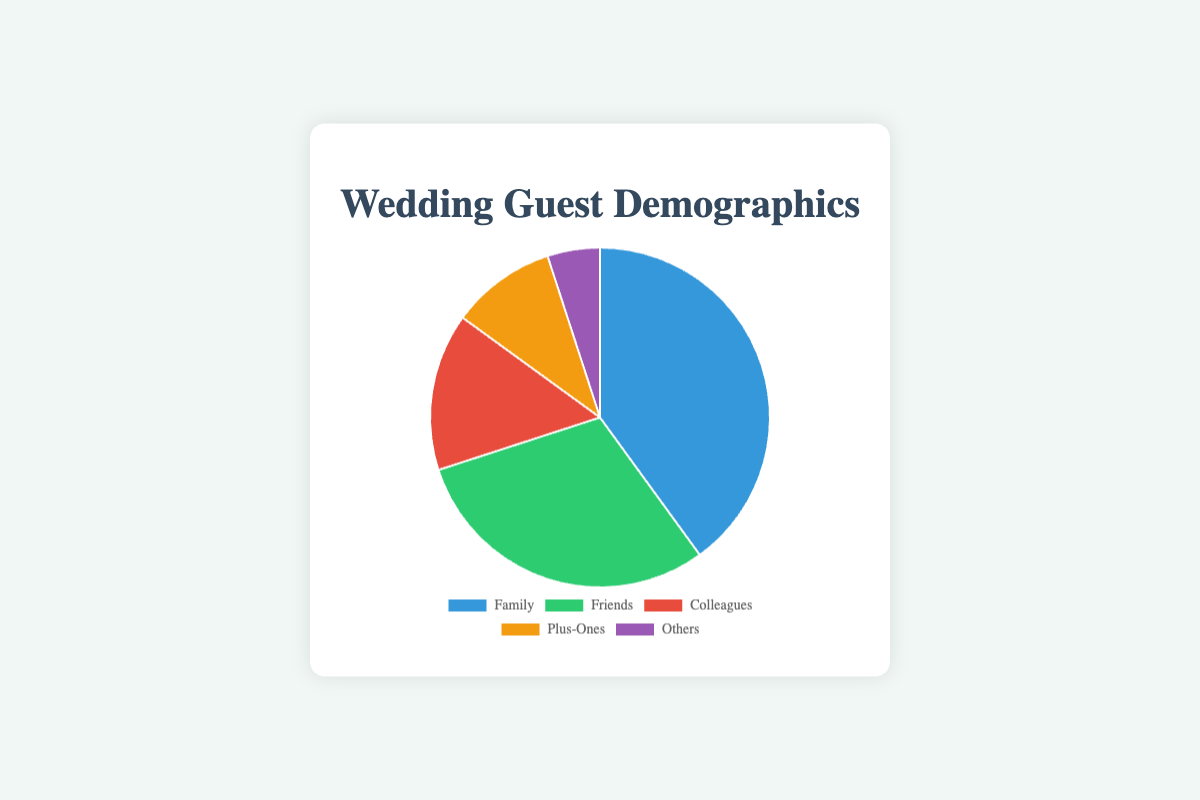what percentage of guests are family members? The category "Family" is labeled with a value of 40%. Thus, family members make up 40% of the guests.
Answer: 40% How many categories have a percentage greater than 10%? There are three categories with percentages greater than 10%: Family (40%), Friends (30%), and Colleagues (15%).
Answer: 3 Which category has the least representation? The category with the smallest percentage is labeled "Others" with a value of 5%.
Answer: Others What's the combined percentage of Friends and Plus-Ones? Sum the percentages of Friends (30%) and Plus-Ones (10%): 30% + 10% = 40%.
Answer: 40% Do family members or colleagues make up a larger portion of the guest demographics? Compare the percentages for Family (40%) and Colleagues (15%): 40% is greater than 15%. Therefore, family members make up a larger portion.
Answer: Family What is the difference between the percentage of Friends and the percentage of Colleagues? Subtract the percentage of Colleagues (15%) from the percentage of Friends (30%): 30% - 15% = 15%.
Answer: 15% Which two categories combined make up half of the guest demographics? The categories Family (40%) and Plus-Ones (10%) together make up 40% + 10% = 50%, which is half of the guest demographics.
Answer: Family and Plus-Ones What is the average percentage of the categories labeled Family, Friends, and Colleagues? Sum the percentages of Family (40%), Friends (30%), and Colleagues (15%), then divide by 3: (40% + 30% + 15%) / 3 = 28.33%.
Answer: 28.33% What is the total percentage of guests who are either Plus-Ones or Others? Sum the percentages of Plus-Ones (10%) and Others (5%): 10% + 5% = 15%.
Answer: 15% Which category is represented by the blue color in the pie chart? The pie chart uses blue to signify the largest section, which corresponds to "Family" at 40%.
Answer: Family 